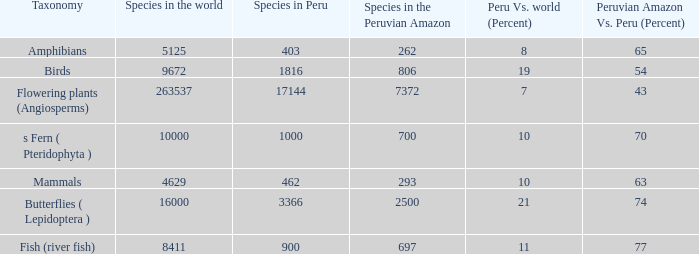What is the species with a 63 percent distribution in the peruvian amazon compared to the whole of peru? 4629.0. 